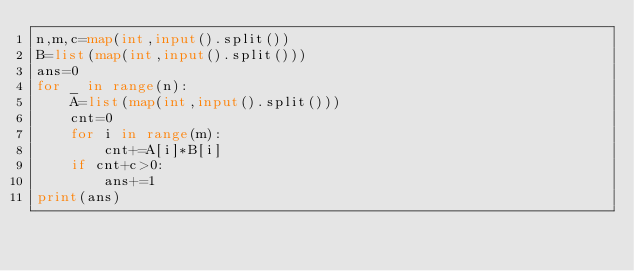<code> <loc_0><loc_0><loc_500><loc_500><_Python_>n,m,c=map(int,input().split())
B=list(map(int,input().split()))
ans=0
for _ in range(n):
    A=list(map(int,input().split()))
    cnt=0
    for i in range(m):
        cnt+=A[i]*B[i]
    if cnt+c>0:
        ans+=1
print(ans)</code> 